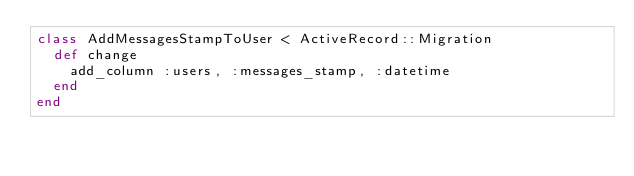Convert code to text. <code><loc_0><loc_0><loc_500><loc_500><_Ruby_>class AddMessagesStampToUser < ActiveRecord::Migration
  def change
    add_column :users, :messages_stamp, :datetime
  end
end
</code> 